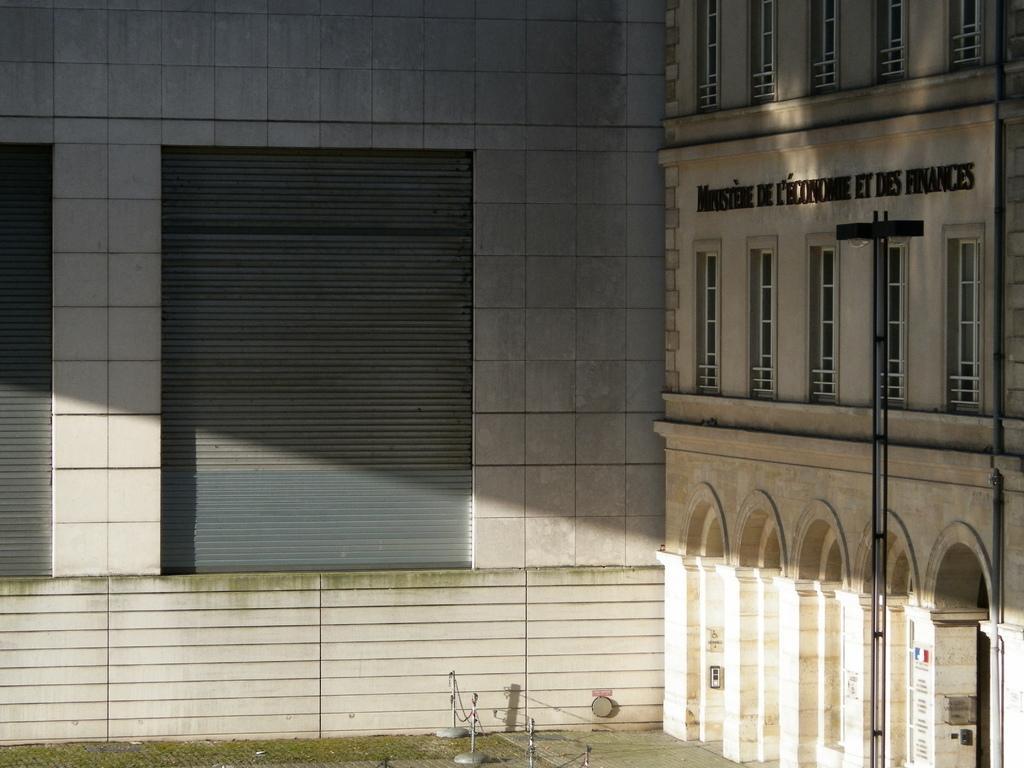How would you summarize this image in a sentence or two? In this image we can see the building and text written on it. And at the side, we can see the wall with shutters. At the bottom there are rods with chains and the grass. 